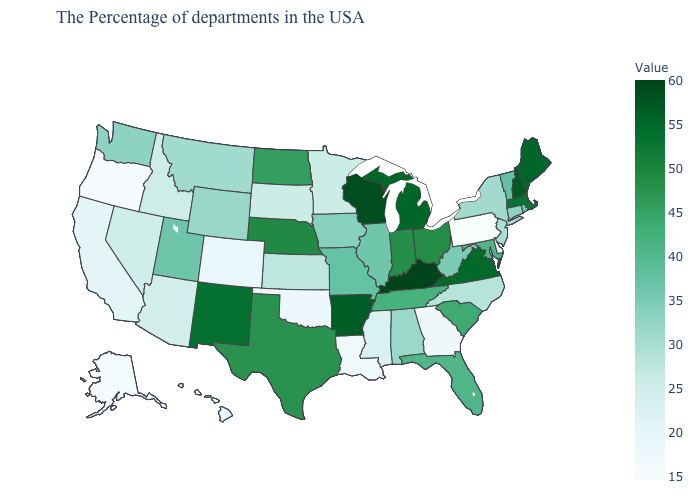Which states have the lowest value in the USA?
Keep it brief. Pennsylvania. Does Oregon have the lowest value in the West?
Give a very brief answer. Yes. Among the states that border Utah , does Nevada have the lowest value?
Quick response, please. No. Does the map have missing data?
Answer briefly. No. Among the states that border Rhode Island , does Massachusetts have the lowest value?
Concise answer only. No. Which states hav the highest value in the West?
Quick response, please. New Mexico. Which states have the highest value in the USA?
Be succinct. Kentucky. Does Missouri have a lower value than New Mexico?
Give a very brief answer. Yes. Among the states that border Connecticut , which have the lowest value?
Give a very brief answer. New York. 